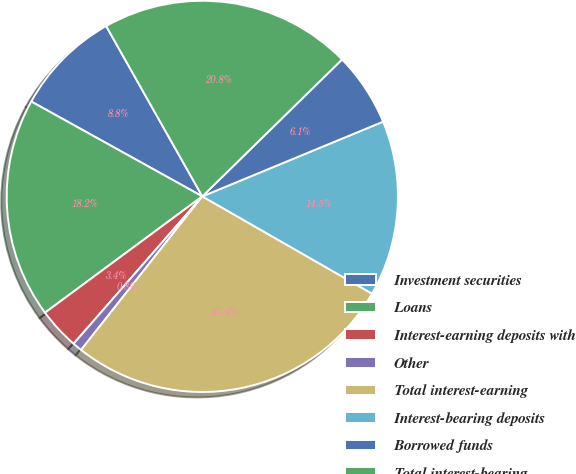<chart> <loc_0><loc_0><loc_500><loc_500><pie_chart><fcel>Investment securities<fcel>Loans<fcel>Interest-earning deposits with<fcel>Other<fcel>Total interest-earning<fcel>Interest-bearing deposits<fcel>Borrowed funds<fcel>Total interest-bearing<nl><fcel>8.76%<fcel>18.19%<fcel>3.44%<fcel>0.79%<fcel>27.35%<fcel>14.52%<fcel>6.1%<fcel>20.84%<nl></chart> 